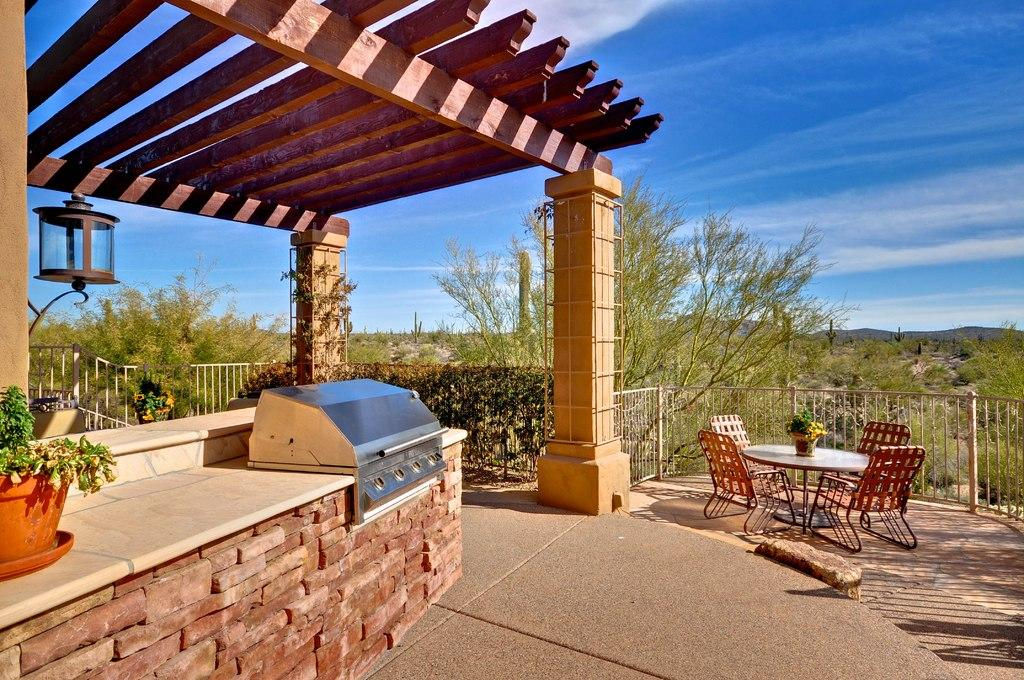What type of furniture is present in the image? There are chairs and a table in the image. What is placed on the table? There is a flower pot on the table. What structure can be seen in the background of the image? There is a shed in the image. What type of vegetation is present in the image? There are plants in the image, and they are green. What is the color of the sky in the image? The sky is blue and white in the image. Where is the amusement park located in the image? There is no amusement park present in the image. What type of rifle can be seen in the image? There is no rifle present in the image. 